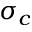Convert formula to latex. <formula><loc_0><loc_0><loc_500><loc_500>\sigma _ { c }</formula> 